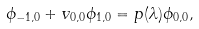Convert formula to latex. <formula><loc_0><loc_0><loc_500><loc_500>\phi _ { - 1 , 0 } + v _ { 0 , 0 } \phi _ { 1 , 0 } = p ( \lambda ) \phi _ { 0 , 0 } ,</formula> 